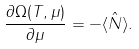Convert formula to latex. <formula><loc_0><loc_0><loc_500><loc_500>\frac { \partial \Omega ( T , \mu ) } { \partial \mu } = - \langle \hat { N } \rangle .</formula> 